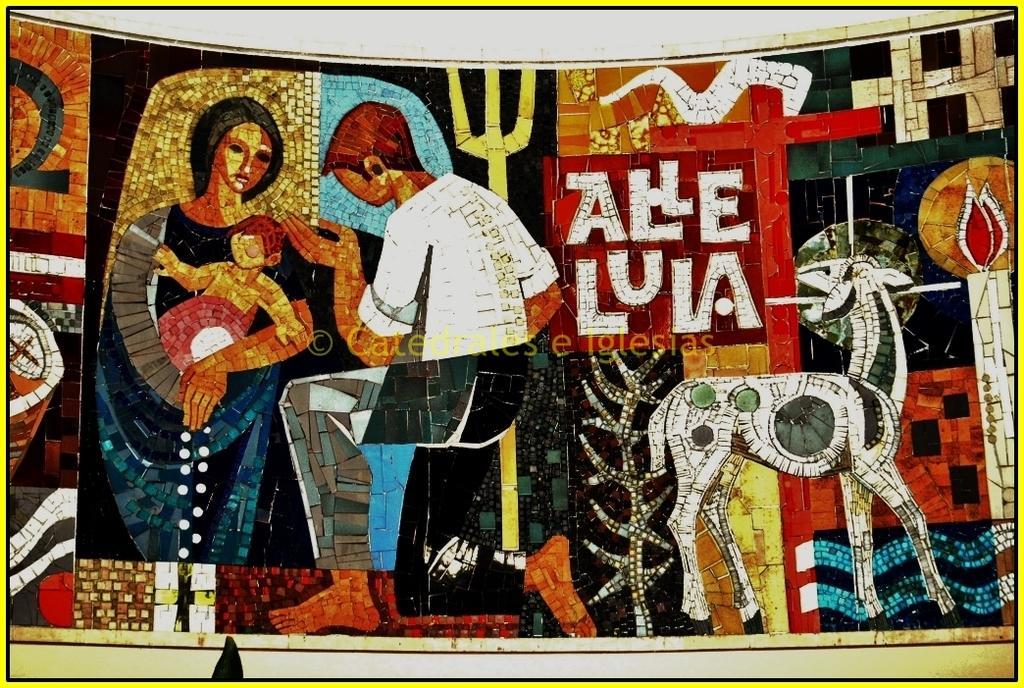In one or two sentences, can you explain what this image depicts? This image consists of a poster with many images and a text on it. 